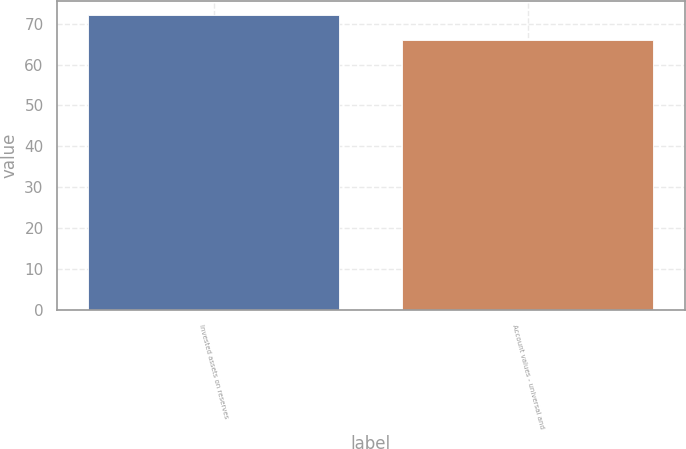Convert chart to OTSL. <chart><loc_0><loc_0><loc_500><loc_500><bar_chart><fcel>Invested assets on reserves<fcel>Account values - universal and<nl><fcel>72<fcel>66<nl></chart> 